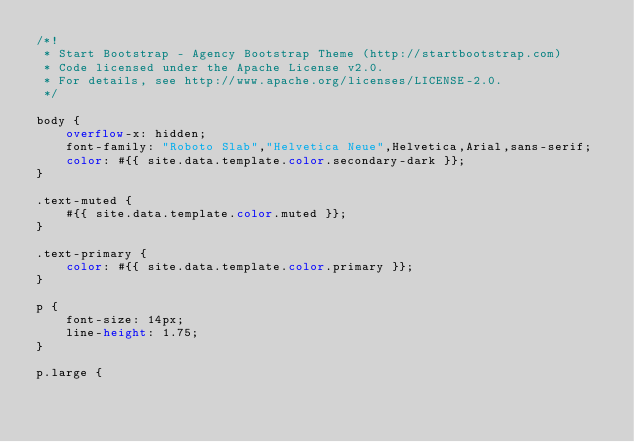Convert code to text. <code><loc_0><loc_0><loc_500><loc_500><_CSS_>/*!
 * Start Bootstrap - Agency Bootstrap Theme (http://startbootstrap.com)
 * Code licensed under the Apache License v2.0.
 * For details, see http://www.apache.org/licenses/LICENSE-2.0.
 */

body {
    overflow-x: hidden;
    font-family: "Roboto Slab","Helvetica Neue",Helvetica,Arial,sans-serif;
    color: #{{ site.data.template.color.secondary-dark }};
}

.text-muted {
    #{{ site.data.template.color.muted }};
}

.text-primary {
    color: #{{ site.data.template.color.primary }};
}

p {
    font-size: 14px;
    line-height: 1.75;
}

p.large {</code> 